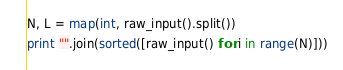<code> <loc_0><loc_0><loc_500><loc_500><_Python_>N, L = map(int, raw_input().split())
print "".join(sorted([raw_input() for i in range(N)]))</code> 